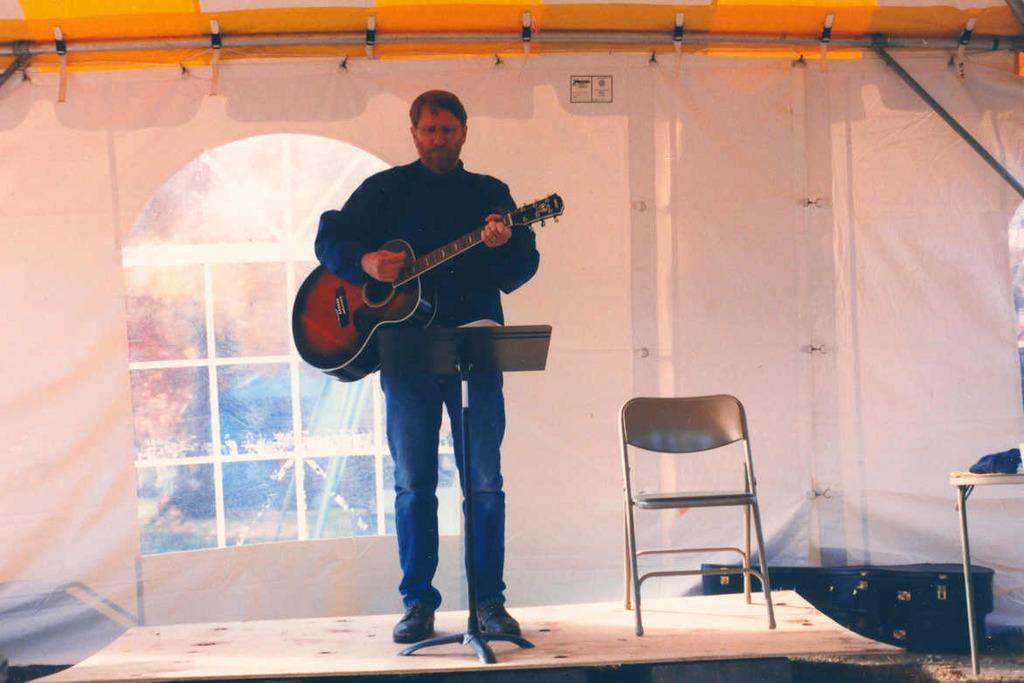What is the man in the image doing? The man is playing a guitar in the image. What can be seen in the background of the image? There is a window in the image. What type of furniture is present on stage in the image? There is a chair on stage in the image. What items are related to the guitar in the image? There are guitar bags in the image. What type of animals can be seen at the zoo in the image? There is no zoo present in the image; it features a man playing a guitar, a window, a chair on stage, and guitar bags. 